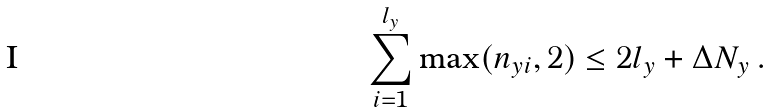<formula> <loc_0><loc_0><loc_500><loc_500>\sum _ { i = 1 } ^ { l _ { y } } \max ( n _ { y } { _ { i } } , 2 ) \leq 2 l _ { y } + \Delta N _ { y } \, .</formula> 